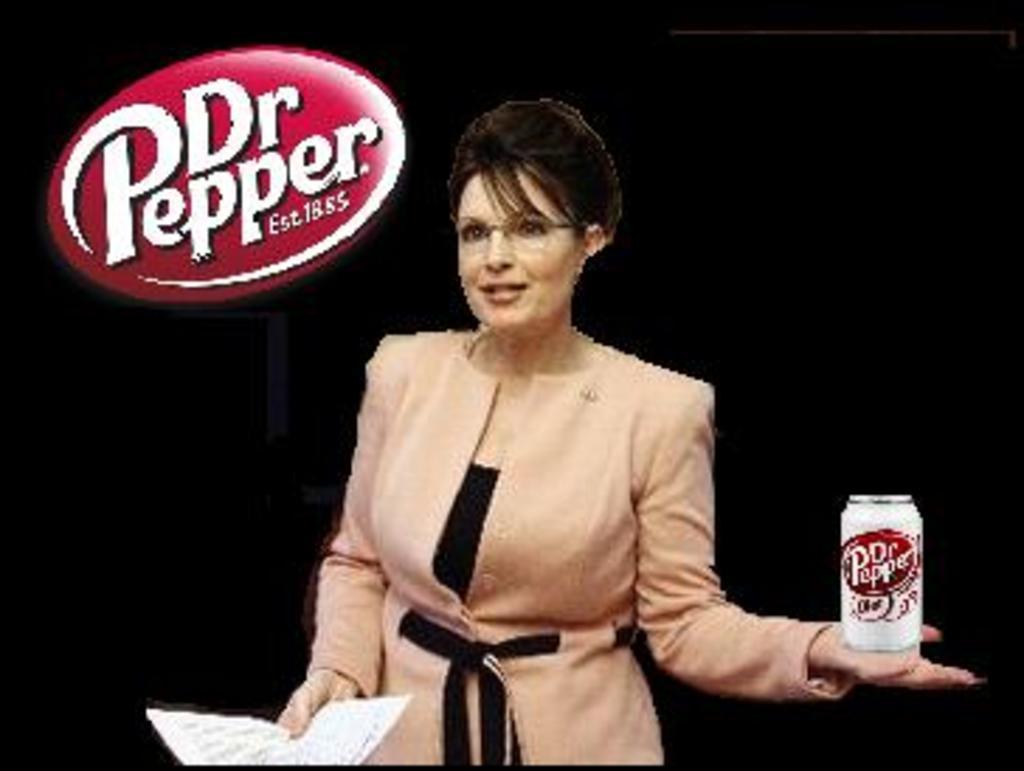How would you summarize this image in a sentence or two? This is an edited image, we can see there is a woman holding a paper and a can. Behind the woman there is a dark background and on the image there is a logo. 